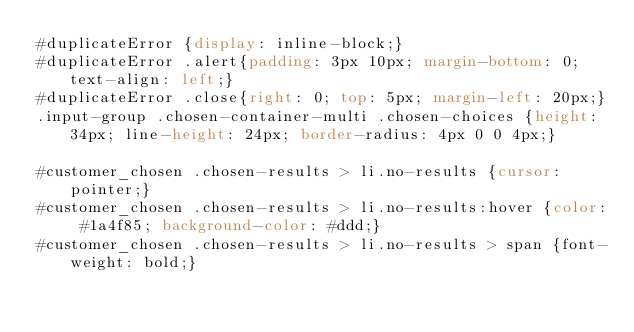<code> <loc_0><loc_0><loc_500><loc_500><_CSS_>#duplicateError {display: inline-block;}
#duplicateError .alert{padding: 3px 10px; margin-bottom: 0; text-align: left;}
#duplicateError .close{right: 0; top: 5px; margin-left: 20px;} 
.input-group .chosen-container-multi .chosen-choices {height: 34px; line-height: 24px; border-radius: 4px 0 0 4px;}

#customer_chosen .chosen-results > li.no-results {cursor: pointer;}
#customer_chosen .chosen-results > li.no-results:hover {color: #1a4f85; background-color: #ddd;}
#customer_chosen .chosen-results > li.no-results > span {font-weight: bold;}
</code> 